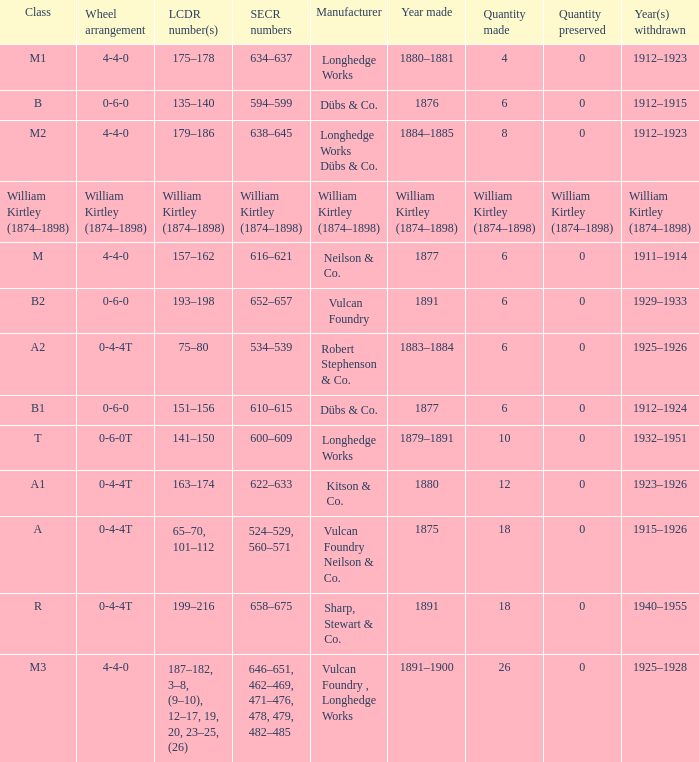Which SECR numbers have a class of b1? 610–615. 